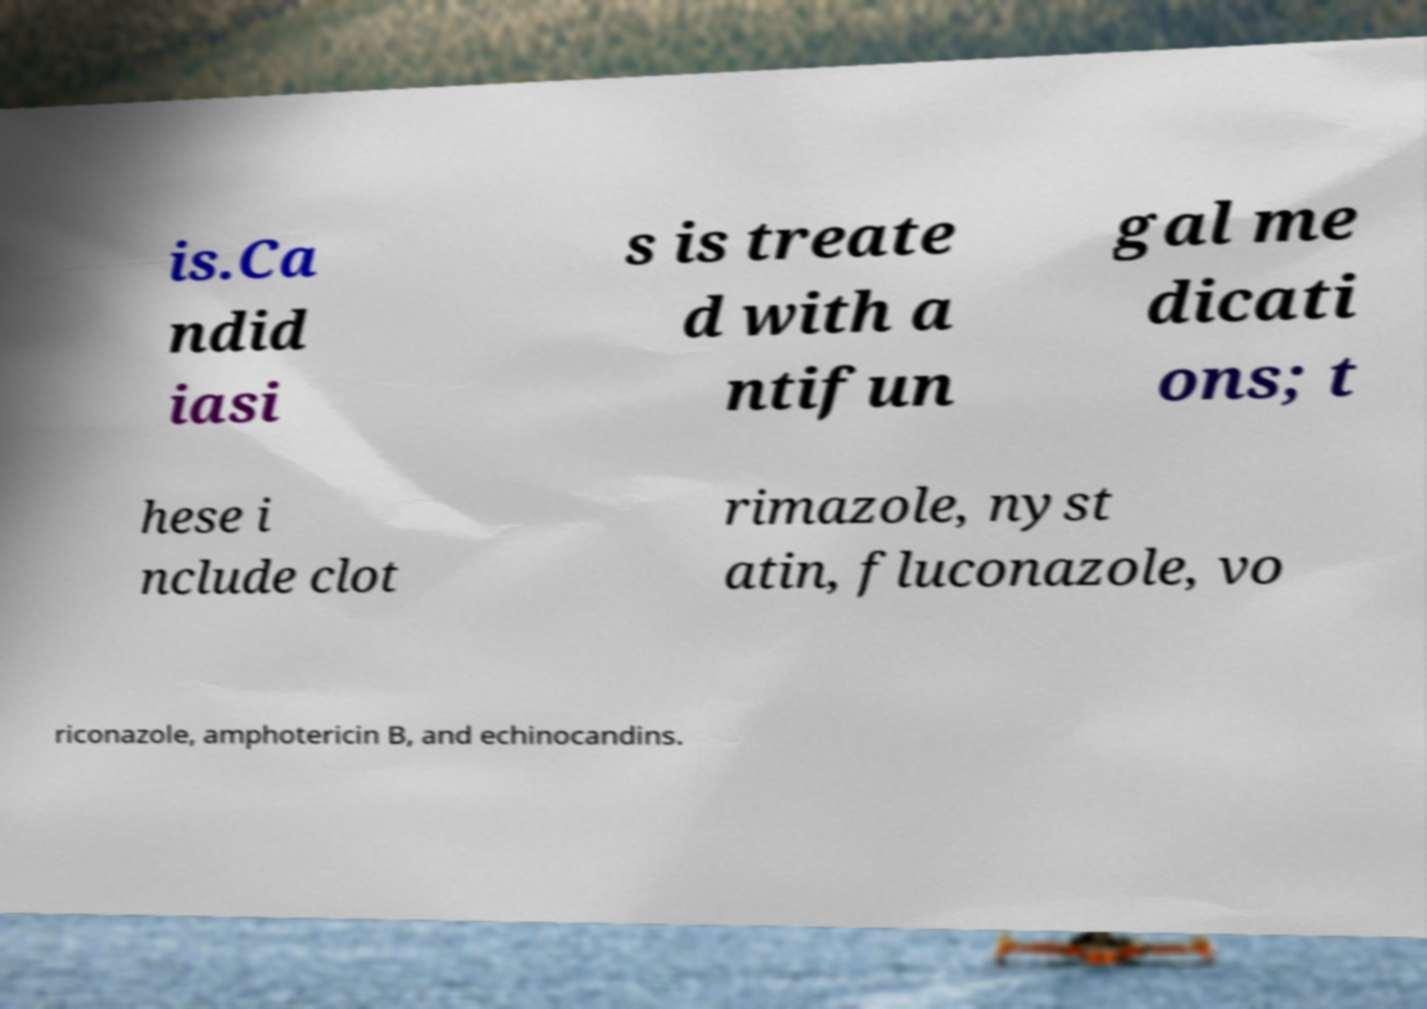There's text embedded in this image that I need extracted. Can you transcribe it verbatim? is.Ca ndid iasi s is treate d with a ntifun gal me dicati ons; t hese i nclude clot rimazole, nyst atin, fluconazole, vo riconazole, amphotericin B, and echinocandins. 